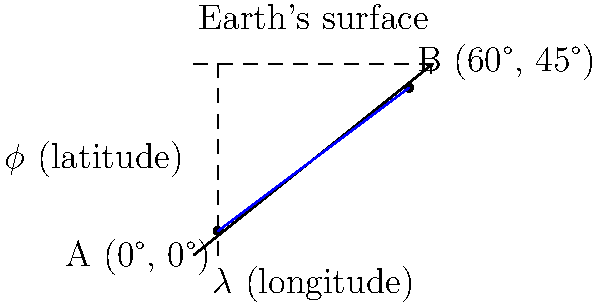As a citizen scientist tracking bird migration, you've received data points for two sightings of a rare species. The first sighting (point A) was at 0° latitude and 0° longitude, while the second sighting (point B) was at 45° N latitude and 60° E longitude. Assuming the Earth is a perfect sphere with a radius of 6,371 km, calculate the great-circle distance between these two points using the haversine formula. Round your answer to the nearest kilometer. To solve this problem, we'll use the haversine formula for great-circle distance:

1) The haversine formula is:
   $$a = \sin^2(\frac{\Delta\phi}{2}) + \cos(\phi_1) \cos(\phi_2) \sin^2(\frac{\Delta\lambda}{2})$$
   $$c = 2 \arctan2(\sqrt{a}, \sqrt{1-a})$$
   $$d = R c$$

   Where $\phi$ is latitude, $\lambda$ is longitude, and $R$ is Earth's radius.

2) Convert degrees to radians:
   $\phi_1 = 0° = 0$ rad
   $\phi_2 = 45° = \frac{\pi}{4}$ rad
   $\Delta\lambda = 60° = \frac{\pi}{3}$ rad

3) Calculate $a$:
   $$a = \sin^2(\frac{\frac{\pi}{4}}{2}) + \cos(0) \cos(\frac{\pi}{4}) \sin^2(\frac{\frac{\pi}{3}}{2})$$
   $$a = \sin^2(\frac{\pi}{8}) + \cos(\frac{\pi}{4}) \sin^2(\frac{\pi}{6})$$
   $$a \approx 0.2588$$

4) Calculate $c$:
   $$c = 2 \arctan2(\sqrt{0.2588}, \sqrt{1-0.2588})$$
   $$c \approx 1.0472$$

5) Calculate distance $d$:
   $$d = 6371 \times 1.0472 \approx 6671.7 \text{ km}$$

6) Rounding to the nearest kilometer:
   $$d \approx 6672 \text{ km}$$
Answer: 6672 km 